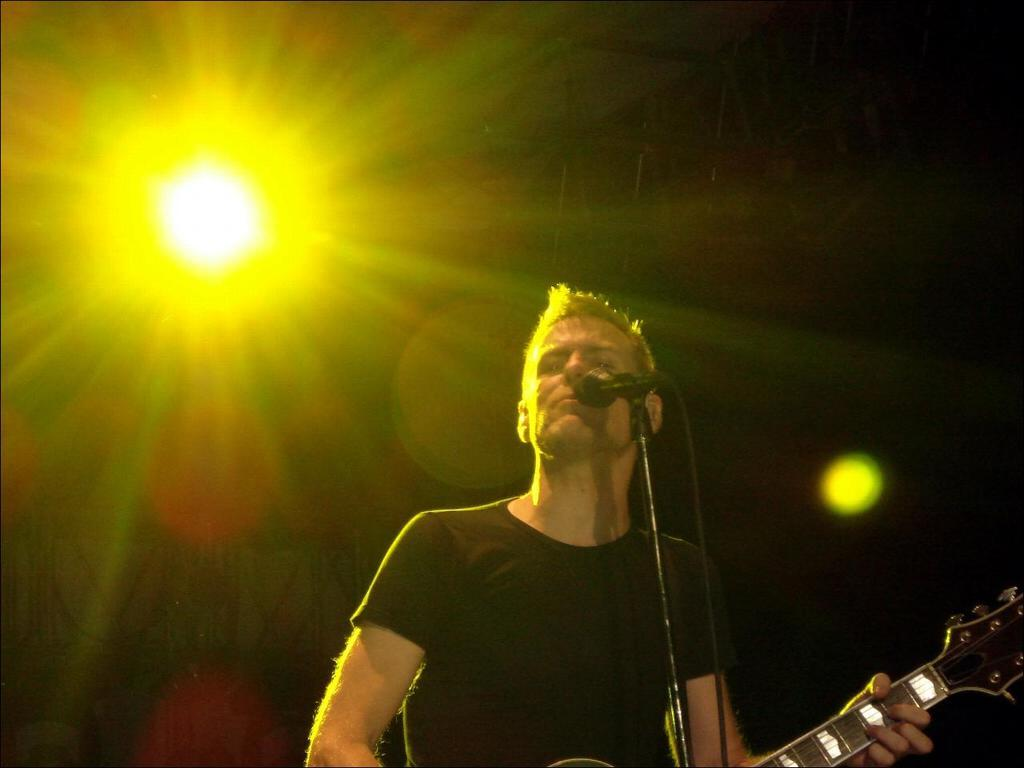What is the person in the image doing? The person is playing a guitar. What object is present in the image that is commonly used for amplifying sound? There is a microphone in the image. What can be seen in the background of the image? There is a light in the background of the image. What part of the competition is the person in the image participating in? There is no competition present in the image; it only shows a person playing a guitar and a microphone. 